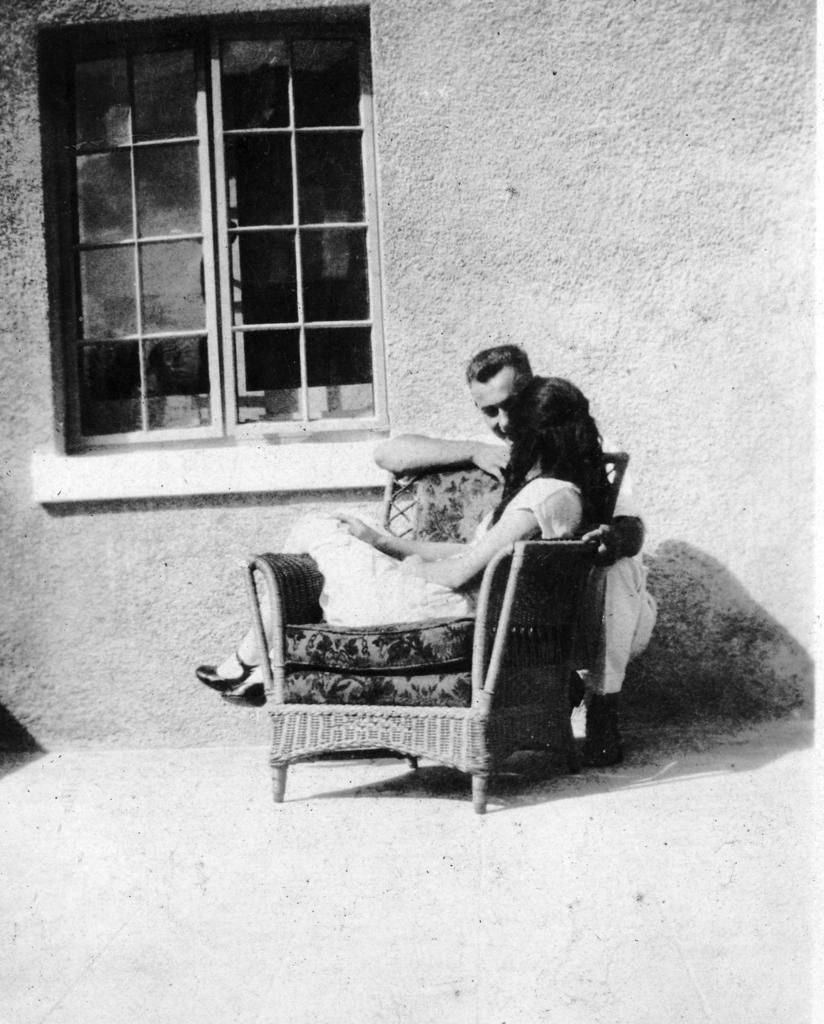What can be seen in the image that provides a view of the outside? There is a window in the image that provides a view of the outside. What is the color of the wall behind the woman? The wall in the image is white. What is the woman doing in the image? The woman is sitting on a chair. Can you describe the man's position in relation to the woman? There is a man behind the chair where the woman is sitting. What type of reward is the woman holding in the image? There is no reward visible in the image; the woman is sitting on a chair. What kind of toy can be seen in the hands of the man behind the chair? There is no toy present in the image; the man is not holding anything. 